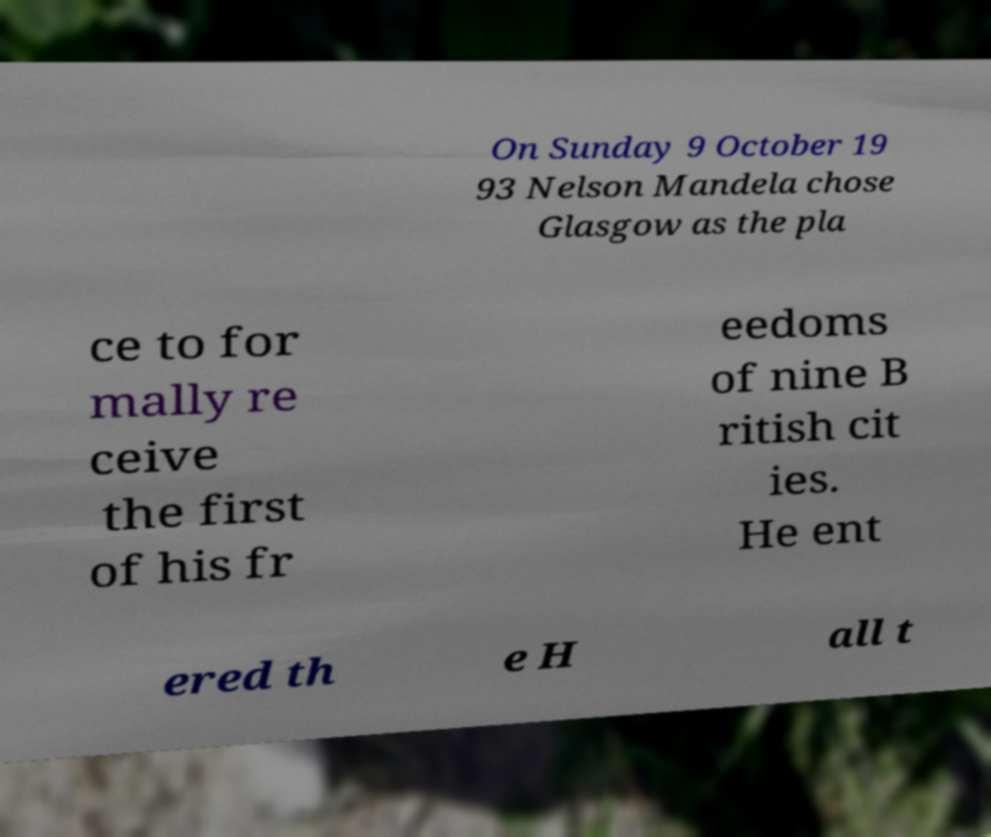I need the written content from this picture converted into text. Can you do that? On Sunday 9 October 19 93 Nelson Mandela chose Glasgow as the pla ce to for mally re ceive the first of his fr eedoms of nine B ritish cit ies. He ent ered th e H all t 